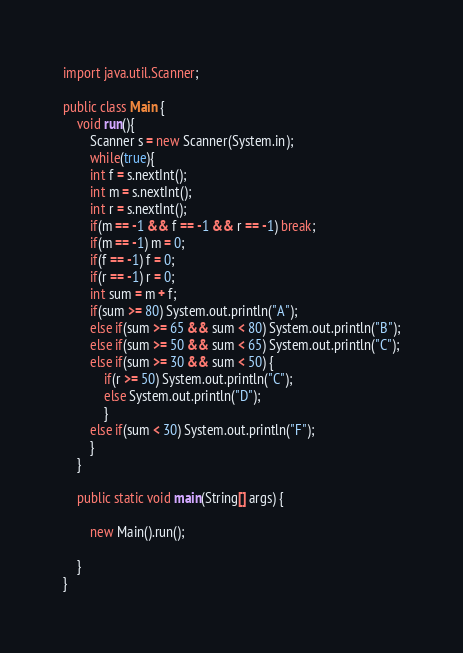Convert code to text. <code><loc_0><loc_0><loc_500><loc_500><_Java_>import java.util.Scanner;

public class Main {
	void run(){
		Scanner s = new Scanner(System.in);
		while(true){
		int f = s.nextInt();
		int m = s.nextInt();
		int r = s.nextInt();
		if(m == -1 && f == -1 && r == -1) break;
		if(m == -1) m = 0;
		if(f == -1) f = 0;
		if(r == -1) r = 0;
		int sum = m + f; 
		if(sum >= 80) System.out.println("A");
		else if(sum >= 65 && sum < 80) System.out.println("B");
		else if(sum >= 50 && sum < 65) System.out.println("C");
		else if(sum >= 30 && sum < 50) {
			if(r >= 50) System.out.println("C");
			else System.out.println("D");
			}
		else if(sum < 30) System.out.println("F");
		}
	}

	public static void main(String[] args) {
	
		new Main().run();
		
	}
}</code> 